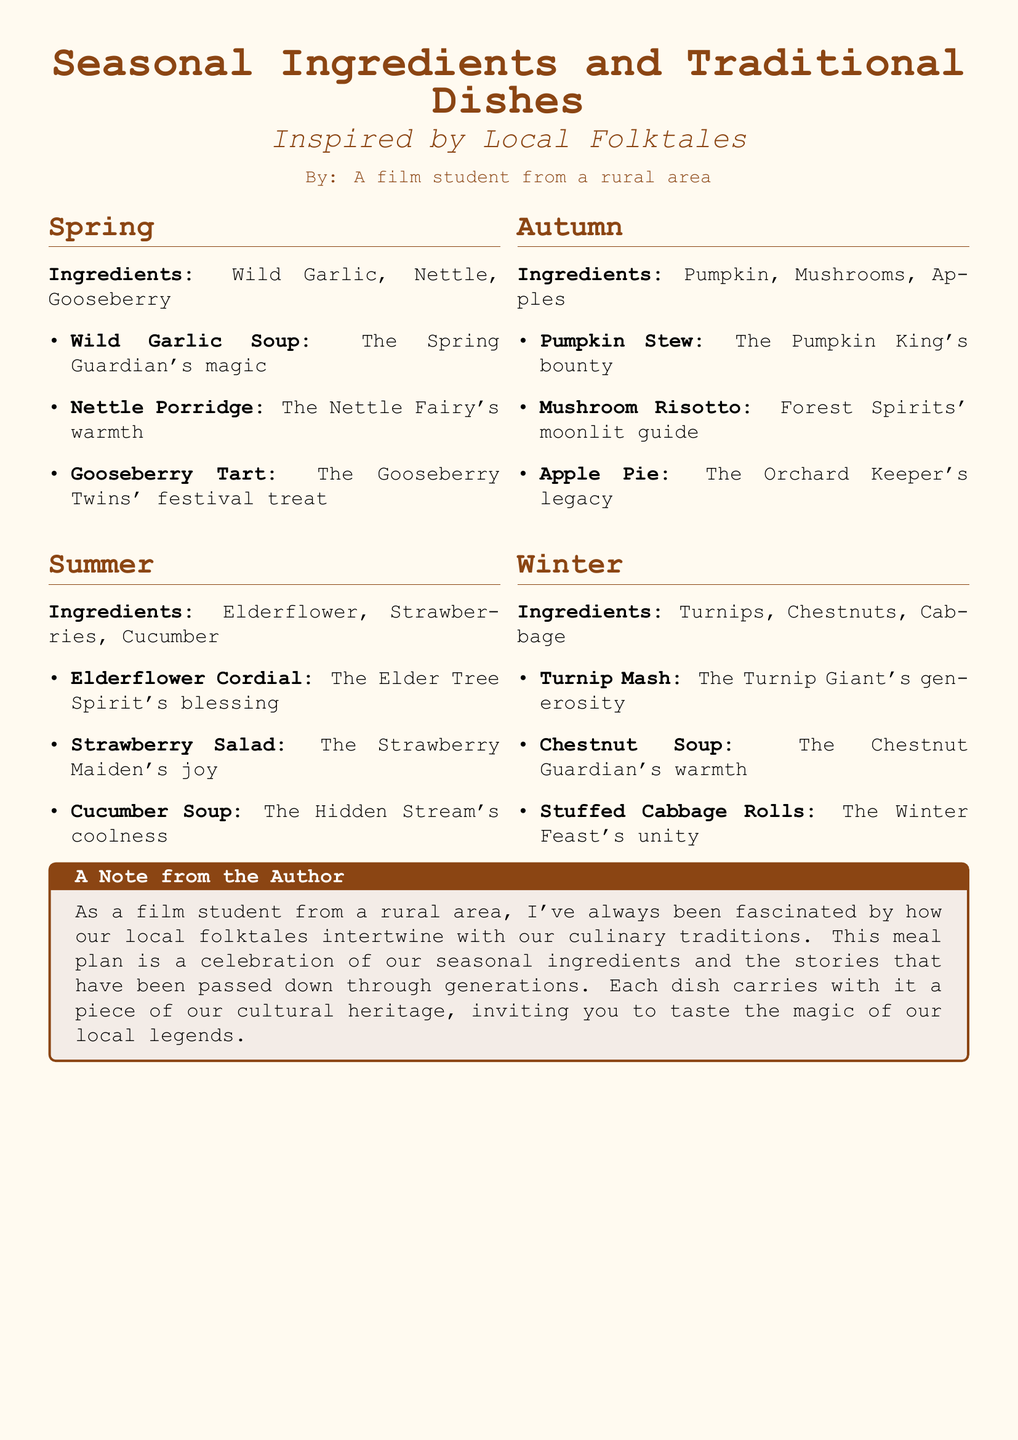What are the spring ingredients? The ingredients listed for spring are Wild Garlic, Nettle, and Gooseberry.
Answer: Wild Garlic, Nettle, Gooseberry What dish represents the Nettle Fairy? The document specifies that the Nettle Porridge represents the Nettle Fairy's warmth.
Answer: Nettle Porridge What is the title of the meal plan? The title of the meal plan is "Seasonal Ingredients and Traditional Dishes Inspired by Local Folktales."
Answer: Seasonal Ingredients and Traditional Dishes Which spirit blesses the Elderflower Cordial? The Elder Tree Spirit is mentioned as blessing the Elderflower Cordial.
Answer: Elder Tree Spirit What does the Pumpkin King's bounty refer to? The document specifies that Pumpkin Stew refers to the Pumpkin King's bounty.
Answer: Pumpkin Stew What seasonal ingredient is associated with winter? The ingredients associated with winter include Turnips, Chestnuts, and Cabbage.
Answer: Turnips, Chestnuts, Cabbage How many dishes are listed for autumn? There are three dishes listed for autumn: Pumpkin Stew, Mushroom Risotto, and Apple Pie.
Answer: Three What is the purpose of the meal plan? The meal plan is a celebration of seasonal ingredients and the stories that have been passed down through generations.
Answer: Celebration of seasonal ingredients and stories Who wrote the note from the author? The note from the author is written by a film student from a rural area.
Answer: A film student from a rural area 